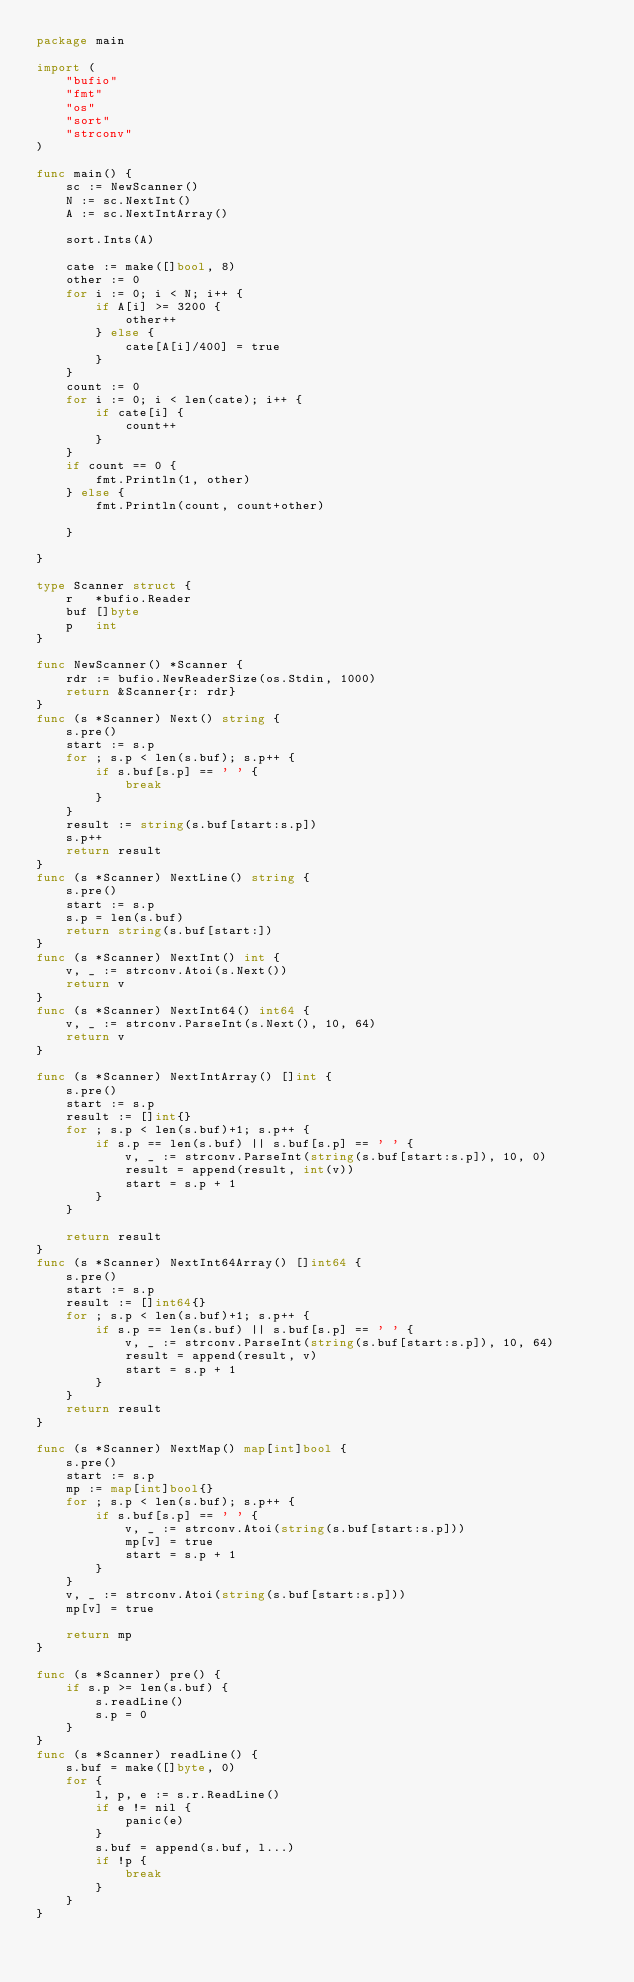Convert code to text. <code><loc_0><loc_0><loc_500><loc_500><_Go_>package main

import (
	"bufio"
	"fmt"
	"os"
	"sort"
	"strconv"
)

func main() {
	sc := NewScanner()
	N := sc.NextInt()
	A := sc.NextIntArray()

	sort.Ints(A)

	cate := make([]bool, 8)
	other := 0
	for i := 0; i < N; i++ {
		if A[i] >= 3200 {
			other++
		} else {
			cate[A[i]/400] = true
		}
	}
	count := 0
	for i := 0; i < len(cate); i++ {
		if cate[i] {
			count++
		}
	}
	if count == 0 {
		fmt.Println(1, other)
	} else {
		fmt.Println(count, count+other)

	}

}

type Scanner struct {
	r   *bufio.Reader
	buf []byte
	p   int
}

func NewScanner() *Scanner {
	rdr := bufio.NewReaderSize(os.Stdin, 1000)
	return &Scanner{r: rdr}
}
func (s *Scanner) Next() string {
	s.pre()
	start := s.p
	for ; s.p < len(s.buf); s.p++ {
		if s.buf[s.p] == ' ' {
			break
		}
	}
	result := string(s.buf[start:s.p])
	s.p++
	return result
}
func (s *Scanner) NextLine() string {
	s.pre()
	start := s.p
	s.p = len(s.buf)
	return string(s.buf[start:])
}
func (s *Scanner) NextInt() int {
	v, _ := strconv.Atoi(s.Next())
	return v
}
func (s *Scanner) NextInt64() int64 {
	v, _ := strconv.ParseInt(s.Next(), 10, 64)
	return v
}

func (s *Scanner) NextIntArray() []int {
	s.pre()
	start := s.p
	result := []int{}
	for ; s.p < len(s.buf)+1; s.p++ {
		if s.p == len(s.buf) || s.buf[s.p] == ' ' {
			v, _ := strconv.ParseInt(string(s.buf[start:s.p]), 10, 0)
			result = append(result, int(v))
			start = s.p + 1
		}
	}

	return result
}
func (s *Scanner) NextInt64Array() []int64 {
	s.pre()
	start := s.p
	result := []int64{}
	for ; s.p < len(s.buf)+1; s.p++ {
		if s.p == len(s.buf) || s.buf[s.p] == ' ' {
			v, _ := strconv.ParseInt(string(s.buf[start:s.p]), 10, 64)
			result = append(result, v)
			start = s.p + 1
		}
	}
	return result
}

func (s *Scanner) NextMap() map[int]bool {
	s.pre()
	start := s.p
	mp := map[int]bool{}
	for ; s.p < len(s.buf); s.p++ {
		if s.buf[s.p] == ' ' {
			v, _ := strconv.Atoi(string(s.buf[start:s.p]))
			mp[v] = true
			start = s.p + 1
		}
	}
	v, _ := strconv.Atoi(string(s.buf[start:s.p]))
	mp[v] = true

	return mp
}

func (s *Scanner) pre() {
	if s.p >= len(s.buf) {
		s.readLine()
		s.p = 0
	}
}
func (s *Scanner) readLine() {
	s.buf = make([]byte, 0)
	for {
		l, p, e := s.r.ReadLine()
		if e != nil {
			panic(e)
		}
		s.buf = append(s.buf, l...)
		if !p {
			break
		}
	}
}
</code> 